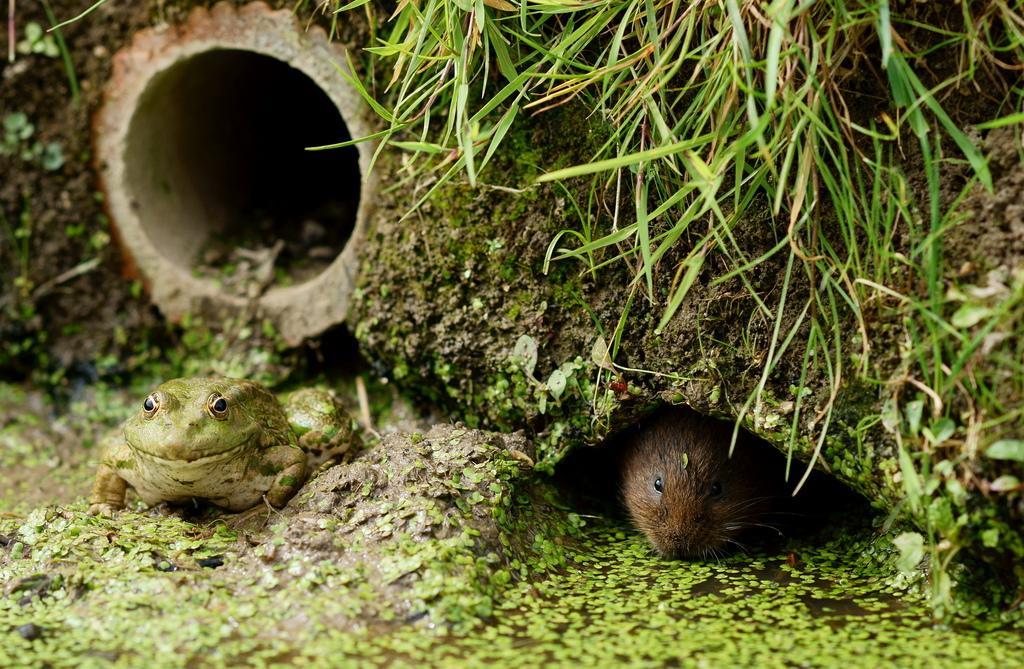Can you describe this image briefly? Here in this picture we can see a frog and a rat present on the ground and we can see a pipe present in the ground and we can see grass also present on the ground. 